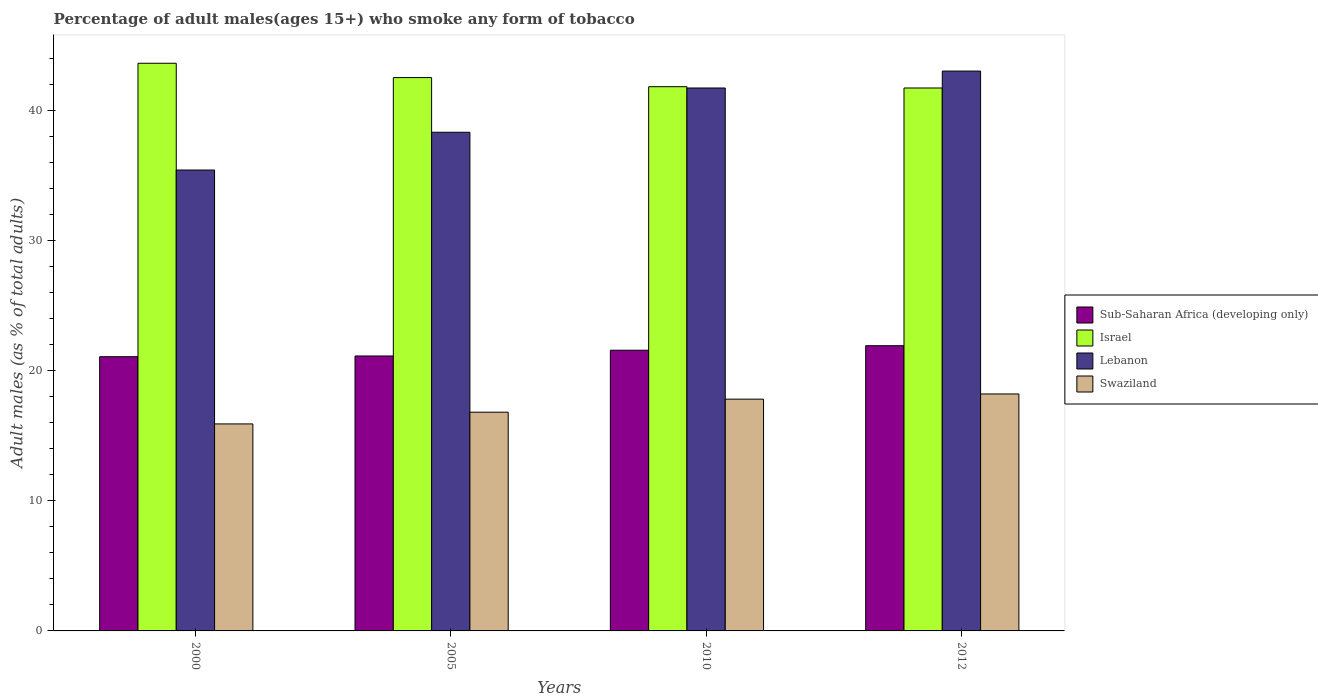How many different coloured bars are there?
Provide a short and direct response. 4. How many groups of bars are there?
Your response must be concise. 4. Are the number of bars per tick equal to the number of legend labels?
Offer a terse response. Yes. Are the number of bars on each tick of the X-axis equal?
Provide a succinct answer. Yes. What is the label of the 3rd group of bars from the left?
Provide a short and direct response. 2010. What is the percentage of adult males who smoke in Israel in 2010?
Offer a terse response. 41.8. Across all years, what is the maximum percentage of adult males who smoke in Sub-Saharan Africa (developing only)?
Provide a short and direct response. 21.91. Across all years, what is the minimum percentage of adult males who smoke in Israel?
Your response must be concise. 41.7. In which year was the percentage of adult males who smoke in Sub-Saharan Africa (developing only) maximum?
Give a very brief answer. 2012. In which year was the percentage of adult males who smoke in Israel minimum?
Offer a terse response. 2012. What is the total percentage of adult males who smoke in Sub-Saharan Africa (developing only) in the graph?
Offer a terse response. 85.64. What is the difference between the percentage of adult males who smoke in Sub-Saharan Africa (developing only) in 2005 and that in 2012?
Offer a terse response. -0.79. What is the difference between the percentage of adult males who smoke in Swaziland in 2000 and the percentage of adult males who smoke in Sub-Saharan Africa (developing only) in 2010?
Offer a terse response. -5.66. What is the average percentage of adult males who smoke in Israel per year?
Offer a very short reply. 42.4. In the year 2000, what is the difference between the percentage of adult males who smoke in Lebanon and percentage of adult males who smoke in Sub-Saharan Africa (developing only)?
Your answer should be compact. 14.34. What is the ratio of the percentage of adult males who smoke in Israel in 2000 to that in 2012?
Provide a succinct answer. 1.05. What is the difference between the highest and the second highest percentage of adult males who smoke in Lebanon?
Make the answer very short. 1.3. What is the difference between the highest and the lowest percentage of adult males who smoke in Swaziland?
Your answer should be compact. 2.3. Is the sum of the percentage of adult males who smoke in Israel in 2000 and 2010 greater than the maximum percentage of adult males who smoke in Sub-Saharan Africa (developing only) across all years?
Give a very brief answer. Yes. Is it the case that in every year, the sum of the percentage of adult males who smoke in Israel and percentage of adult males who smoke in Swaziland is greater than the sum of percentage of adult males who smoke in Lebanon and percentage of adult males who smoke in Sub-Saharan Africa (developing only)?
Give a very brief answer. Yes. What does the 4th bar from the right in 2012 represents?
Offer a terse response. Sub-Saharan Africa (developing only). Are all the bars in the graph horizontal?
Offer a very short reply. No. How many years are there in the graph?
Your response must be concise. 4. What is the difference between two consecutive major ticks on the Y-axis?
Provide a succinct answer. 10. Are the values on the major ticks of Y-axis written in scientific E-notation?
Your answer should be very brief. No. Does the graph contain grids?
Offer a terse response. No. What is the title of the graph?
Keep it short and to the point. Percentage of adult males(ages 15+) who smoke any form of tobacco. Does "Hungary" appear as one of the legend labels in the graph?
Your response must be concise. No. What is the label or title of the Y-axis?
Give a very brief answer. Adult males (as % of total adults). What is the Adult males (as % of total adults) of Sub-Saharan Africa (developing only) in 2000?
Keep it short and to the point. 21.06. What is the Adult males (as % of total adults) of Israel in 2000?
Offer a very short reply. 43.6. What is the Adult males (as % of total adults) of Lebanon in 2000?
Your answer should be very brief. 35.4. What is the Adult males (as % of total adults) of Swaziland in 2000?
Offer a terse response. 15.9. What is the Adult males (as % of total adults) in Sub-Saharan Africa (developing only) in 2005?
Offer a terse response. 21.12. What is the Adult males (as % of total adults) in Israel in 2005?
Ensure brevity in your answer.  42.5. What is the Adult males (as % of total adults) in Lebanon in 2005?
Keep it short and to the point. 38.3. What is the Adult males (as % of total adults) in Swaziland in 2005?
Offer a terse response. 16.8. What is the Adult males (as % of total adults) in Sub-Saharan Africa (developing only) in 2010?
Your answer should be very brief. 21.56. What is the Adult males (as % of total adults) of Israel in 2010?
Give a very brief answer. 41.8. What is the Adult males (as % of total adults) in Lebanon in 2010?
Make the answer very short. 41.7. What is the Adult males (as % of total adults) of Sub-Saharan Africa (developing only) in 2012?
Provide a short and direct response. 21.91. What is the Adult males (as % of total adults) in Israel in 2012?
Your answer should be compact. 41.7. What is the Adult males (as % of total adults) of Lebanon in 2012?
Offer a terse response. 43. Across all years, what is the maximum Adult males (as % of total adults) of Sub-Saharan Africa (developing only)?
Provide a short and direct response. 21.91. Across all years, what is the maximum Adult males (as % of total adults) of Israel?
Your answer should be compact. 43.6. Across all years, what is the maximum Adult males (as % of total adults) of Swaziland?
Keep it short and to the point. 18.2. Across all years, what is the minimum Adult males (as % of total adults) of Sub-Saharan Africa (developing only)?
Your answer should be compact. 21.06. Across all years, what is the minimum Adult males (as % of total adults) in Israel?
Provide a succinct answer. 41.7. Across all years, what is the minimum Adult males (as % of total adults) of Lebanon?
Keep it short and to the point. 35.4. Across all years, what is the minimum Adult males (as % of total adults) of Swaziland?
Give a very brief answer. 15.9. What is the total Adult males (as % of total adults) of Sub-Saharan Africa (developing only) in the graph?
Offer a terse response. 85.64. What is the total Adult males (as % of total adults) of Israel in the graph?
Offer a terse response. 169.6. What is the total Adult males (as % of total adults) of Lebanon in the graph?
Your response must be concise. 158.4. What is the total Adult males (as % of total adults) in Swaziland in the graph?
Keep it short and to the point. 68.7. What is the difference between the Adult males (as % of total adults) of Sub-Saharan Africa (developing only) in 2000 and that in 2005?
Ensure brevity in your answer.  -0.06. What is the difference between the Adult males (as % of total adults) in Sub-Saharan Africa (developing only) in 2000 and that in 2010?
Offer a very short reply. -0.5. What is the difference between the Adult males (as % of total adults) in Sub-Saharan Africa (developing only) in 2000 and that in 2012?
Provide a succinct answer. -0.85. What is the difference between the Adult males (as % of total adults) in Lebanon in 2000 and that in 2012?
Give a very brief answer. -7.6. What is the difference between the Adult males (as % of total adults) in Sub-Saharan Africa (developing only) in 2005 and that in 2010?
Provide a succinct answer. -0.44. What is the difference between the Adult males (as % of total adults) of Sub-Saharan Africa (developing only) in 2005 and that in 2012?
Provide a succinct answer. -0.79. What is the difference between the Adult males (as % of total adults) of Israel in 2005 and that in 2012?
Ensure brevity in your answer.  0.8. What is the difference between the Adult males (as % of total adults) in Lebanon in 2005 and that in 2012?
Make the answer very short. -4.7. What is the difference between the Adult males (as % of total adults) of Sub-Saharan Africa (developing only) in 2010 and that in 2012?
Your answer should be compact. -0.35. What is the difference between the Adult males (as % of total adults) of Israel in 2010 and that in 2012?
Keep it short and to the point. 0.1. What is the difference between the Adult males (as % of total adults) in Sub-Saharan Africa (developing only) in 2000 and the Adult males (as % of total adults) in Israel in 2005?
Offer a very short reply. -21.44. What is the difference between the Adult males (as % of total adults) in Sub-Saharan Africa (developing only) in 2000 and the Adult males (as % of total adults) in Lebanon in 2005?
Ensure brevity in your answer.  -17.24. What is the difference between the Adult males (as % of total adults) in Sub-Saharan Africa (developing only) in 2000 and the Adult males (as % of total adults) in Swaziland in 2005?
Your response must be concise. 4.26. What is the difference between the Adult males (as % of total adults) of Israel in 2000 and the Adult males (as % of total adults) of Lebanon in 2005?
Ensure brevity in your answer.  5.3. What is the difference between the Adult males (as % of total adults) in Israel in 2000 and the Adult males (as % of total adults) in Swaziland in 2005?
Keep it short and to the point. 26.8. What is the difference between the Adult males (as % of total adults) of Lebanon in 2000 and the Adult males (as % of total adults) of Swaziland in 2005?
Your answer should be compact. 18.6. What is the difference between the Adult males (as % of total adults) in Sub-Saharan Africa (developing only) in 2000 and the Adult males (as % of total adults) in Israel in 2010?
Give a very brief answer. -20.74. What is the difference between the Adult males (as % of total adults) of Sub-Saharan Africa (developing only) in 2000 and the Adult males (as % of total adults) of Lebanon in 2010?
Your answer should be very brief. -20.64. What is the difference between the Adult males (as % of total adults) in Sub-Saharan Africa (developing only) in 2000 and the Adult males (as % of total adults) in Swaziland in 2010?
Your response must be concise. 3.26. What is the difference between the Adult males (as % of total adults) in Israel in 2000 and the Adult males (as % of total adults) in Lebanon in 2010?
Give a very brief answer. 1.9. What is the difference between the Adult males (as % of total adults) in Israel in 2000 and the Adult males (as % of total adults) in Swaziland in 2010?
Provide a short and direct response. 25.8. What is the difference between the Adult males (as % of total adults) in Lebanon in 2000 and the Adult males (as % of total adults) in Swaziland in 2010?
Give a very brief answer. 17.6. What is the difference between the Adult males (as % of total adults) of Sub-Saharan Africa (developing only) in 2000 and the Adult males (as % of total adults) of Israel in 2012?
Your response must be concise. -20.64. What is the difference between the Adult males (as % of total adults) in Sub-Saharan Africa (developing only) in 2000 and the Adult males (as % of total adults) in Lebanon in 2012?
Offer a terse response. -21.94. What is the difference between the Adult males (as % of total adults) in Sub-Saharan Africa (developing only) in 2000 and the Adult males (as % of total adults) in Swaziland in 2012?
Offer a terse response. 2.86. What is the difference between the Adult males (as % of total adults) in Israel in 2000 and the Adult males (as % of total adults) in Lebanon in 2012?
Offer a very short reply. 0.6. What is the difference between the Adult males (as % of total adults) of Israel in 2000 and the Adult males (as % of total adults) of Swaziland in 2012?
Offer a terse response. 25.4. What is the difference between the Adult males (as % of total adults) in Lebanon in 2000 and the Adult males (as % of total adults) in Swaziland in 2012?
Offer a terse response. 17.2. What is the difference between the Adult males (as % of total adults) in Sub-Saharan Africa (developing only) in 2005 and the Adult males (as % of total adults) in Israel in 2010?
Provide a short and direct response. -20.68. What is the difference between the Adult males (as % of total adults) of Sub-Saharan Africa (developing only) in 2005 and the Adult males (as % of total adults) of Lebanon in 2010?
Provide a short and direct response. -20.58. What is the difference between the Adult males (as % of total adults) in Sub-Saharan Africa (developing only) in 2005 and the Adult males (as % of total adults) in Swaziland in 2010?
Your answer should be compact. 3.32. What is the difference between the Adult males (as % of total adults) of Israel in 2005 and the Adult males (as % of total adults) of Swaziland in 2010?
Your answer should be very brief. 24.7. What is the difference between the Adult males (as % of total adults) in Lebanon in 2005 and the Adult males (as % of total adults) in Swaziland in 2010?
Ensure brevity in your answer.  20.5. What is the difference between the Adult males (as % of total adults) of Sub-Saharan Africa (developing only) in 2005 and the Adult males (as % of total adults) of Israel in 2012?
Your response must be concise. -20.58. What is the difference between the Adult males (as % of total adults) of Sub-Saharan Africa (developing only) in 2005 and the Adult males (as % of total adults) of Lebanon in 2012?
Ensure brevity in your answer.  -21.88. What is the difference between the Adult males (as % of total adults) in Sub-Saharan Africa (developing only) in 2005 and the Adult males (as % of total adults) in Swaziland in 2012?
Offer a terse response. 2.92. What is the difference between the Adult males (as % of total adults) of Israel in 2005 and the Adult males (as % of total adults) of Lebanon in 2012?
Ensure brevity in your answer.  -0.5. What is the difference between the Adult males (as % of total adults) in Israel in 2005 and the Adult males (as % of total adults) in Swaziland in 2012?
Make the answer very short. 24.3. What is the difference between the Adult males (as % of total adults) in Lebanon in 2005 and the Adult males (as % of total adults) in Swaziland in 2012?
Provide a succinct answer. 20.1. What is the difference between the Adult males (as % of total adults) of Sub-Saharan Africa (developing only) in 2010 and the Adult males (as % of total adults) of Israel in 2012?
Your response must be concise. -20.14. What is the difference between the Adult males (as % of total adults) in Sub-Saharan Africa (developing only) in 2010 and the Adult males (as % of total adults) in Lebanon in 2012?
Give a very brief answer. -21.44. What is the difference between the Adult males (as % of total adults) of Sub-Saharan Africa (developing only) in 2010 and the Adult males (as % of total adults) of Swaziland in 2012?
Offer a very short reply. 3.36. What is the difference between the Adult males (as % of total adults) of Israel in 2010 and the Adult males (as % of total adults) of Lebanon in 2012?
Make the answer very short. -1.2. What is the difference between the Adult males (as % of total adults) of Israel in 2010 and the Adult males (as % of total adults) of Swaziland in 2012?
Your answer should be compact. 23.6. What is the difference between the Adult males (as % of total adults) of Lebanon in 2010 and the Adult males (as % of total adults) of Swaziland in 2012?
Keep it short and to the point. 23.5. What is the average Adult males (as % of total adults) in Sub-Saharan Africa (developing only) per year?
Your response must be concise. 21.41. What is the average Adult males (as % of total adults) in Israel per year?
Provide a succinct answer. 42.4. What is the average Adult males (as % of total adults) in Lebanon per year?
Offer a very short reply. 39.6. What is the average Adult males (as % of total adults) in Swaziland per year?
Offer a terse response. 17.18. In the year 2000, what is the difference between the Adult males (as % of total adults) in Sub-Saharan Africa (developing only) and Adult males (as % of total adults) in Israel?
Provide a short and direct response. -22.54. In the year 2000, what is the difference between the Adult males (as % of total adults) in Sub-Saharan Africa (developing only) and Adult males (as % of total adults) in Lebanon?
Your response must be concise. -14.34. In the year 2000, what is the difference between the Adult males (as % of total adults) of Sub-Saharan Africa (developing only) and Adult males (as % of total adults) of Swaziland?
Ensure brevity in your answer.  5.16. In the year 2000, what is the difference between the Adult males (as % of total adults) in Israel and Adult males (as % of total adults) in Swaziland?
Your answer should be compact. 27.7. In the year 2000, what is the difference between the Adult males (as % of total adults) of Lebanon and Adult males (as % of total adults) of Swaziland?
Your answer should be compact. 19.5. In the year 2005, what is the difference between the Adult males (as % of total adults) in Sub-Saharan Africa (developing only) and Adult males (as % of total adults) in Israel?
Give a very brief answer. -21.38. In the year 2005, what is the difference between the Adult males (as % of total adults) in Sub-Saharan Africa (developing only) and Adult males (as % of total adults) in Lebanon?
Your response must be concise. -17.18. In the year 2005, what is the difference between the Adult males (as % of total adults) of Sub-Saharan Africa (developing only) and Adult males (as % of total adults) of Swaziland?
Ensure brevity in your answer.  4.32. In the year 2005, what is the difference between the Adult males (as % of total adults) of Israel and Adult males (as % of total adults) of Lebanon?
Ensure brevity in your answer.  4.2. In the year 2005, what is the difference between the Adult males (as % of total adults) in Israel and Adult males (as % of total adults) in Swaziland?
Give a very brief answer. 25.7. In the year 2005, what is the difference between the Adult males (as % of total adults) in Lebanon and Adult males (as % of total adults) in Swaziland?
Your response must be concise. 21.5. In the year 2010, what is the difference between the Adult males (as % of total adults) in Sub-Saharan Africa (developing only) and Adult males (as % of total adults) in Israel?
Your response must be concise. -20.24. In the year 2010, what is the difference between the Adult males (as % of total adults) in Sub-Saharan Africa (developing only) and Adult males (as % of total adults) in Lebanon?
Provide a short and direct response. -20.14. In the year 2010, what is the difference between the Adult males (as % of total adults) in Sub-Saharan Africa (developing only) and Adult males (as % of total adults) in Swaziland?
Your answer should be very brief. 3.76. In the year 2010, what is the difference between the Adult males (as % of total adults) in Israel and Adult males (as % of total adults) in Swaziland?
Keep it short and to the point. 24. In the year 2010, what is the difference between the Adult males (as % of total adults) of Lebanon and Adult males (as % of total adults) of Swaziland?
Offer a terse response. 23.9. In the year 2012, what is the difference between the Adult males (as % of total adults) in Sub-Saharan Africa (developing only) and Adult males (as % of total adults) in Israel?
Ensure brevity in your answer.  -19.79. In the year 2012, what is the difference between the Adult males (as % of total adults) in Sub-Saharan Africa (developing only) and Adult males (as % of total adults) in Lebanon?
Your answer should be compact. -21.09. In the year 2012, what is the difference between the Adult males (as % of total adults) of Sub-Saharan Africa (developing only) and Adult males (as % of total adults) of Swaziland?
Make the answer very short. 3.71. In the year 2012, what is the difference between the Adult males (as % of total adults) in Israel and Adult males (as % of total adults) in Lebanon?
Give a very brief answer. -1.3. In the year 2012, what is the difference between the Adult males (as % of total adults) of Lebanon and Adult males (as % of total adults) of Swaziland?
Ensure brevity in your answer.  24.8. What is the ratio of the Adult males (as % of total adults) of Israel in 2000 to that in 2005?
Offer a very short reply. 1.03. What is the ratio of the Adult males (as % of total adults) of Lebanon in 2000 to that in 2005?
Give a very brief answer. 0.92. What is the ratio of the Adult males (as % of total adults) in Swaziland in 2000 to that in 2005?
Make the answer very short. 0.95. What is the ratio of the Adult males (as % of total adults) of Sub-Saharan Africa (developing only) in 2000 to that in 2010?
Ensure brevity in your answer.  0.98. What is the ratio of the Adult males (as % of total adults) of Israel in 2000 to that in 2010?
Offer a very short reply. 1.04. What is the ratio of the Adult males (as % of total adults) in Lebanon in 2000 to that in 2010?
Provide a short and direct response. 0.85. What is the ratio of the Adult males (as % of total adults) of Swaziland in 2000 to that in 2010?
Ensure brevity in your answer.  0.89. What is the ratio of the Adult males (as % of total adults) of Sub-Saharan Africa (developing only) in 2000 to that in 2012?
Offer a terse response. 0.96. What is the ratio of the Adult males (as % of total adults) of Israel in 2000 to that in 2012?
Your response must be concise. 1.05. What is the ratio of the Adult males (as % of total adults) in Lebanon in 2000 to that in 2012?
Provide a succinct answer. 0.82. What is the ratio of the Adult males (as % of total adults) in Swaziland in 2000 to that in 2012?
Keep it short and to the point. 0.87. What is the ratio of the Adult males (as % of total adults) in Sub-Saharan Africa (developing only) in 2005 to that in 2010?
Keep it short and to the point. 0.98. What is the ratio of the Adult males (as % of total adults) in Israel in 2005 to that in 2010?
Offer a very short reply. 1.02. What is the ratio of the Adult males (as % of total adults) of Lebanon in 2005 to that in 2010?
Offer a terse response. 0.92. What is the ratio of the Adult males (as % of total adults) in Swaziland in 2005 to that in 2010?
Provide a succinct answer. 0.94. What is the ratio of the Adult males (as % of total adults) of Sub-Saharan Africa (developing only) in 2005 to that in 2012?
Offer a terse response. 0.96. What is the ratio of the Adult males (as % of total adults) of Israel in 2005 to that in 2012?
Your answer should be very brief. 1.02. What is the ratio of the Adult males (as % of total adults) in Lebanon in 2005 to that in 2012?
Give a very brief answer. 0.89. What is the ratio of the Adult males (as % of total adults) of Swaziland in 2005 to that in 2012?
Your answer should be very brief. 0.92. What is the ratio of the Adult males (as % of total adults) in Sub-Saharan Africa (developing only) in 2010 to that in 2012?
Provide a short and direct response. 0.98. What is the ratio of the Adult males (as % of total adults) in Israel in 2010 to that in 2012?
Keep it short and to the point. 1. What is the ratio of the Adult males (as % of total adults) in Lebanon in 2010 to that in 2012?
Provide a succinct answer. 0.97. What is the difference between the highest and the second highest Adult males (as % of total adults) in Sub-Saharan Africa (developing only)?
Ensure brevity in your answer.  0.35. What is the difference between the highest and the second highest Adult males (as % of total adults) in Swaziland?
Your response must be concise. 0.4. What is the difference between the highest and the lowest Adult males (as % of total adults) of Sub-Saharan Africa (developing only)?
Offer a very short reply. 0.85. What is the difference between the highest and the lowest Adult males (as % of total adults) of Israel?
Offer a very short reply. 1.9. 